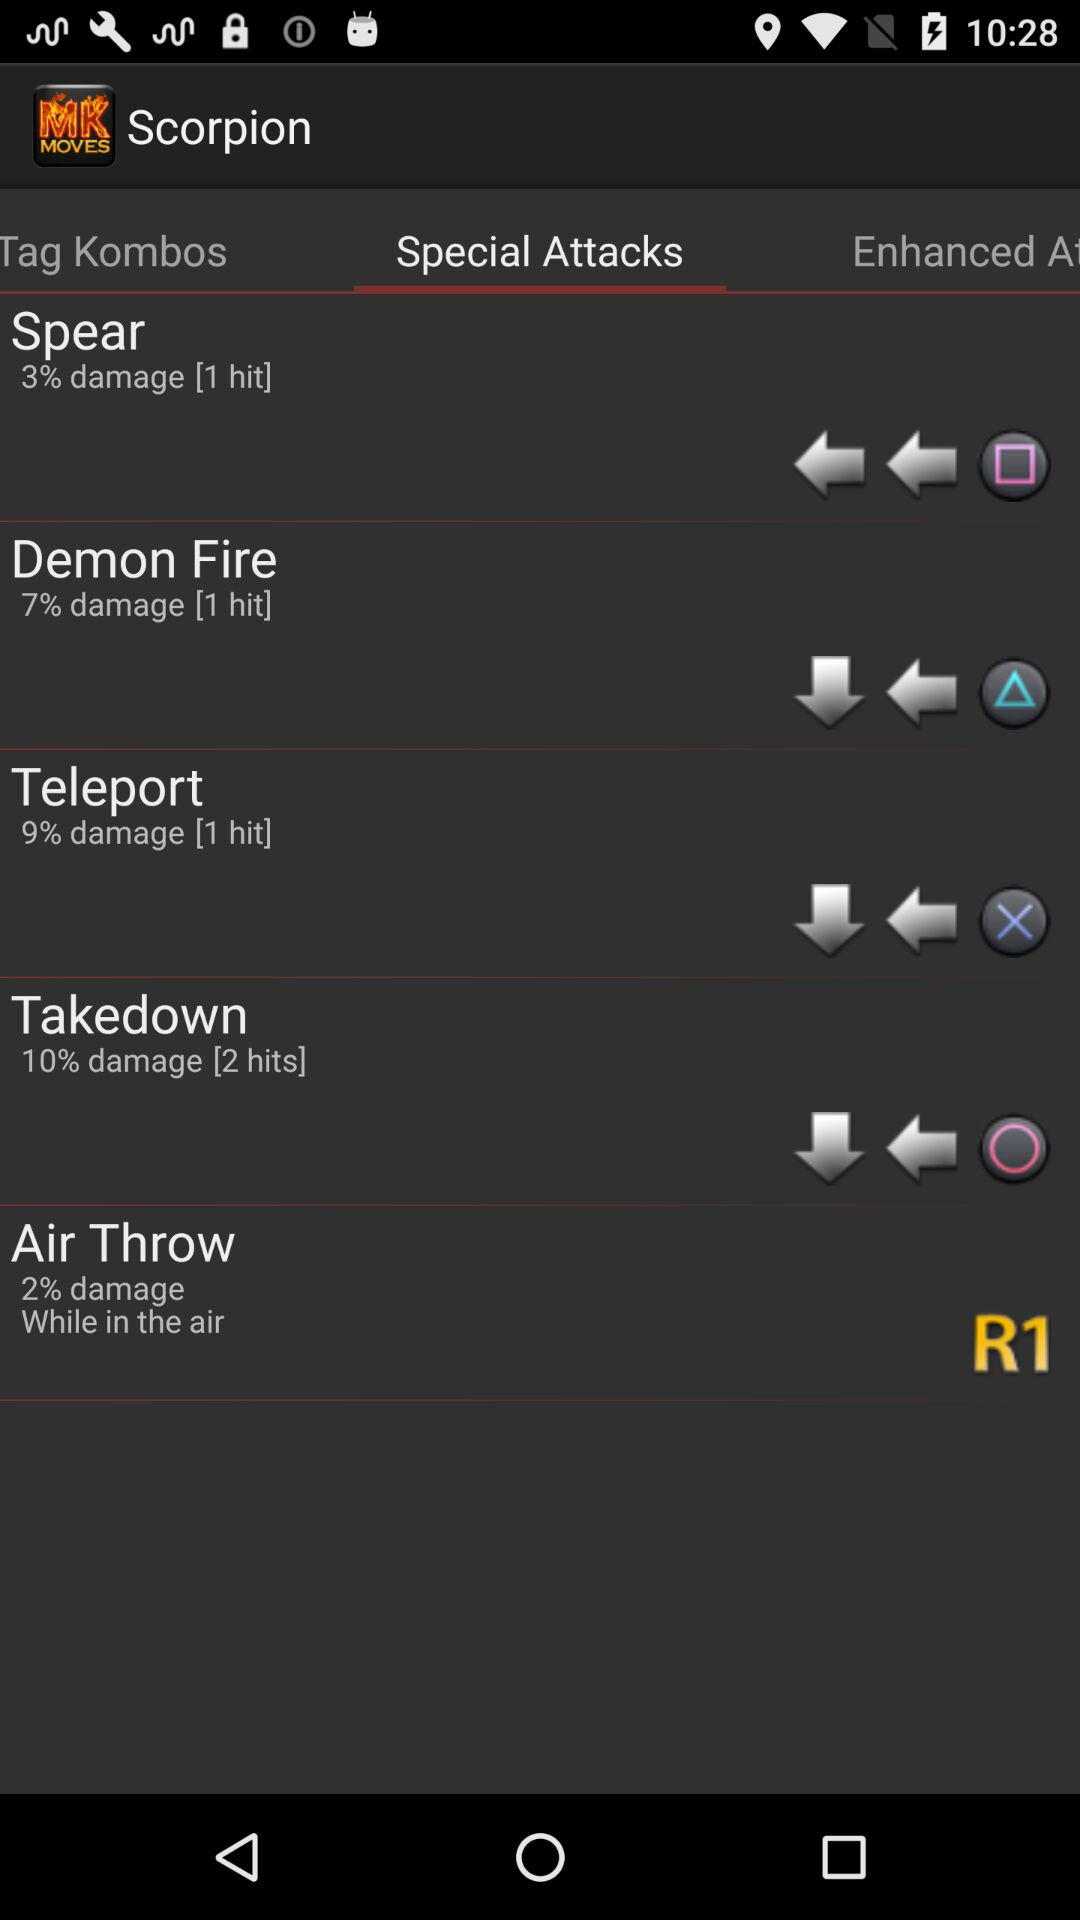How many teleport hits have been recorded? There has been 1 hit recorded. 